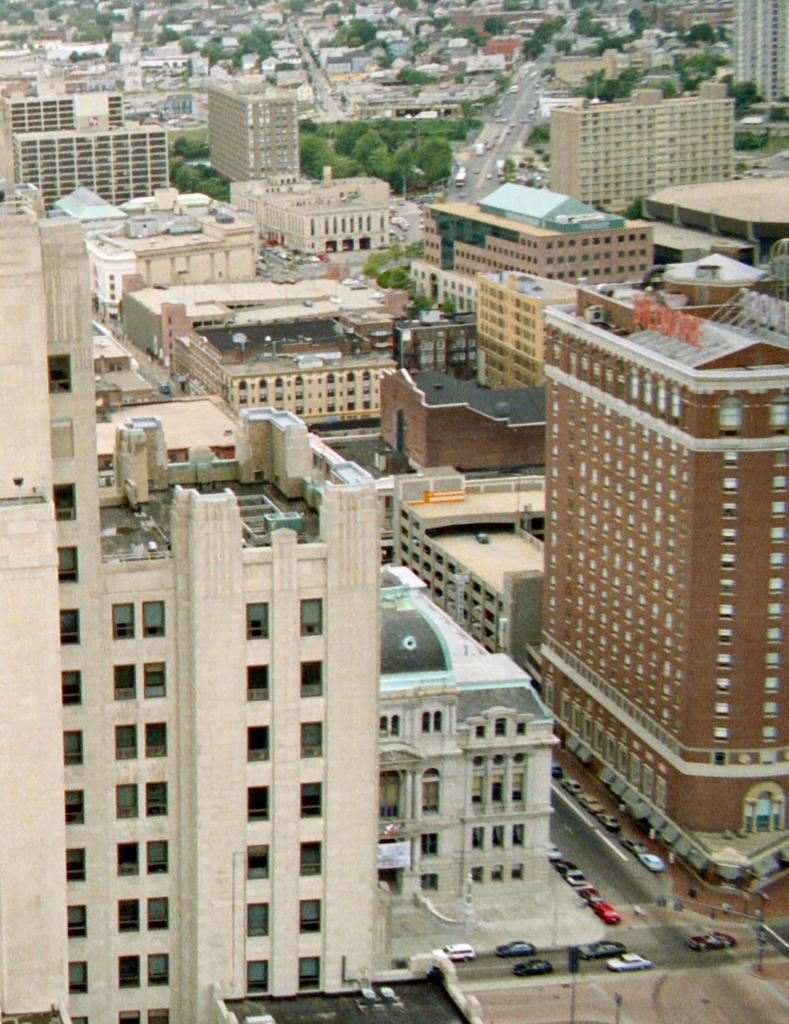Please provide a concise description of this image. This image consists of buildings, houses, trees, light poles, fleets of vehicles on the road and windows. This image is taken may be during a day. 